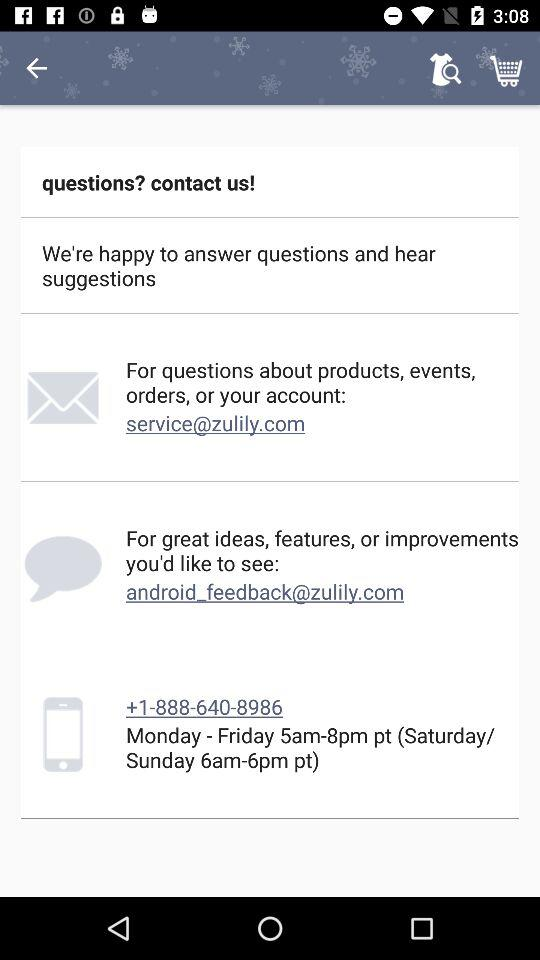What are the timings from Monday to Friday? The timings are 5am-8pm. 